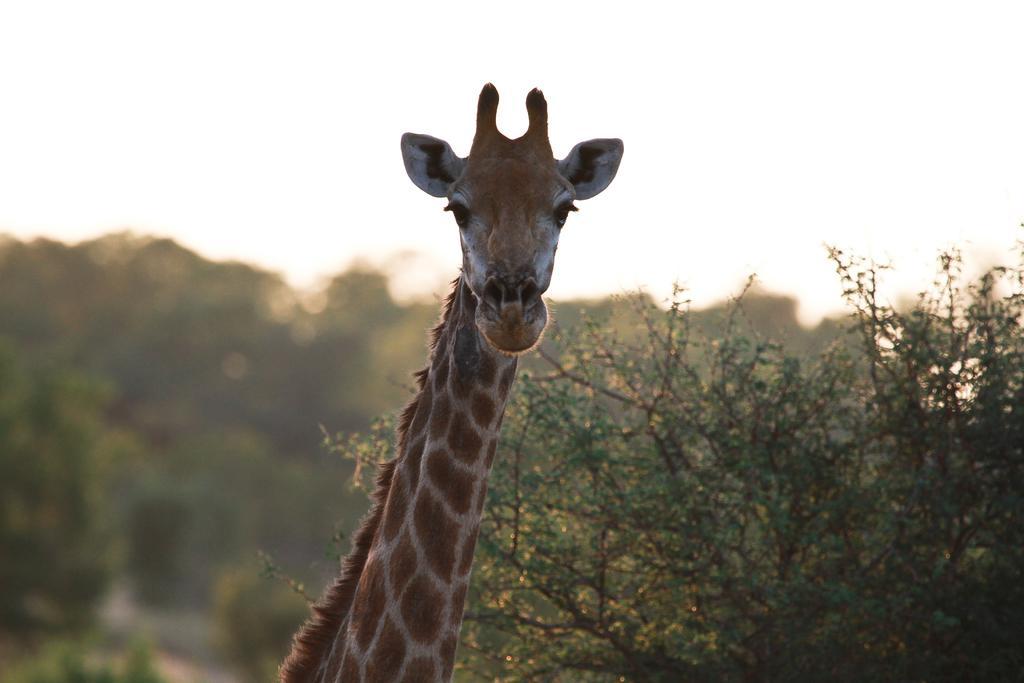Can you describe this image briefly? In this picture we can see brown color giraffe looking in the camera. Behind there are some trees. 